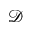<formula> <loc_0><loc_0><loc_500><loc_500>\mathcal { D }</formula> 